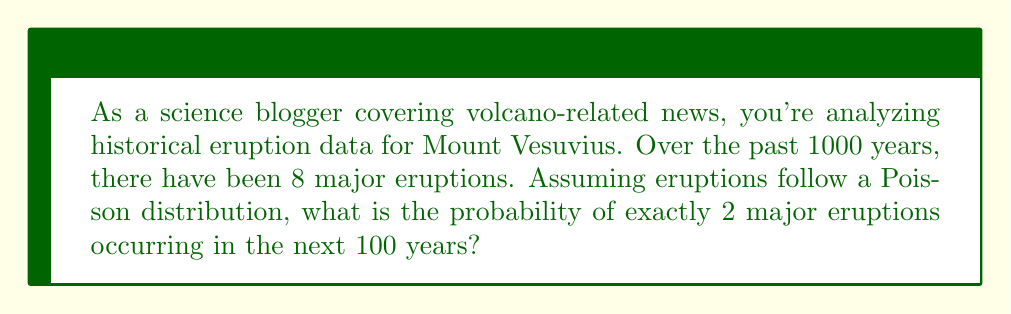Solve this math problem. To solve this problem, we'll use the Poisson distribution, which is often used to model rare events over time. Let's break it down step-by-step:

1. Calculate the rate parameter $\lambda$:
   $\lambda = \frac{\text{number of events}}{\text{time period}} \times \text{new time period}$
   $\lambda = \frac{8 \text{ eruptions}}{1000 \text{ years}} \times 100 \text{ years} = 0.8$

2. The Poisson probability mass function is:
   $$P(X = k) = \frac{e^{-\lambda}\lambda^k}{k!}$$
   Where:
   - $e$ is Euler's number (approximately 2.71828)
   - $\lambda$ is the rate parameter
   - $k$ is the number of events we're calculating the probability for

3. We want the probability of exactly 2 eruptions $(k = 2)$, so let's plug in our values:
   $$P(X = 2) = \frac{e^{-0.8}(0.8)^2}{2!}$$

4. Calculate step-by-step:
   $$P(X = 2) = \frac{e^{-0.8} \times 0.64}{2}$$
   $$P(X = 2) = \frac{0.44933 \times 0.64}{2}$$
   $$P(X = 2) = \frac{0.287571}{2}$$
   $$P(X = 2) = 0.1437855$$

5. Round to four decimal places:
   $$P(X = 2) \approx 0.1438$$
Answer: The probability of exactly 2 major eruptions occurring in the next 100 years is approximately 0.1438 or 14.38%. 